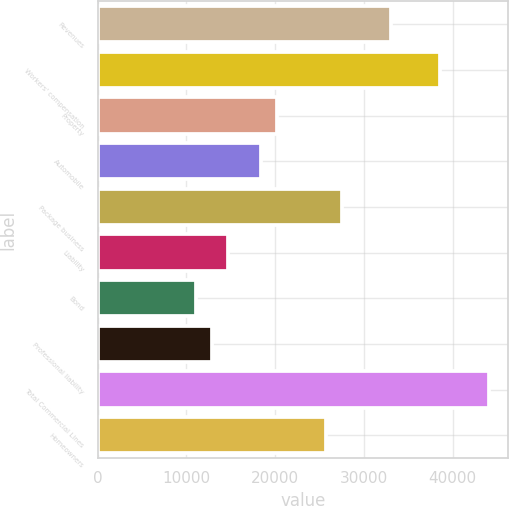<chart> <loc_0><loc_0><loc_500><loc_500><bar_chart><fcel>Revenues<fcel>Workers' compensation<fcel>Property<fcel>Automobile<fcel>Package business<fcel>Liability<fcel>Bond<fcel>Professional liability<fcel>Total Commercial Lines<fcel>Homeowners<nl><fcel>33072.2<fcel>38582.9<fcel>20213.9<fcel>18377<fcel>27561.5<fcel>14703.2<fcel>11029.4<fcel>12866.3<fcel>44093.6<fcel>25724.6<nl></chart> 